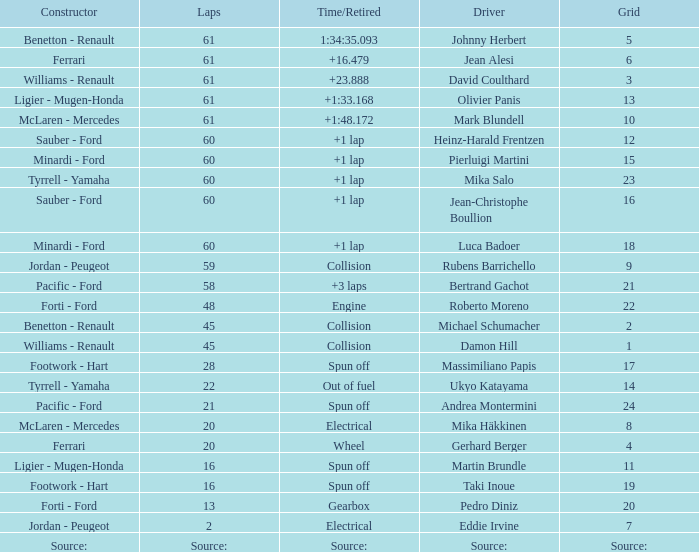Could you help me parse every detail presented in this table? {'header': ['Constructor', 'Laps', 'Time/Retired', 'Driver', 'Grid'], 'rows': [['Benetton - Renault', '61', '1:34:35.093', 'Johnny Herbert', '5'], ['Ferrari', '61', '+16.479', 'Jean Alesi', '6'], ['Williams - Renault', '61', '+23.888', 'David Coulthard', '3'], ['Ligier - Mugen-Honda', '61', '+1:33.168', 'Olivier Panis', '13'], ['McLaren - Mercedes', '61', '+1:48.172', 'Mark Blundell', '10'], ['Sauber - Ford', '60', '+1 lap', 'Heinz-Harald Frentzen', '12'], ['Minardi - Ford', '60', '+1 lap', 'Pierluigi Martini', '15'], ['Tyrrell - Yamaha', '60', '+1 lap', 'Mika Salo', '23'], ['Sauber - Ford', '60', '+1 lap', 'Jean-Christophe Boullion', '16'], ['Minardi - Ford', '60', '+1 lap', 'Luca Badoer', '18'], ['Jordan - Peugeot', '59', 'Collision', 'Rubens Barrichello', '9'], ['Pacific - Ford', '58', '+3 laps', 'Bertrand Gachot', '21'], ['Forti - Ford', '48', 'Engine', 'Roberto Moreno', '22'], ['Benetton - Renault', '45', 'Collision', 'Michael Schumacher', '2'], ['Williams - Renault', '45', 'Collision', 'Damon Hill', '1'], ['Footwork - Hart', '28', 'Spun off', 'Massimiliano Papis', '17'], ['Tyrrell - Yamaha', '22', 'Out of fuel', 'Ukyo Katayama', '14'], ['Pacific - Ford', '21', 'Spun off', 'Andrea Montermini', '24'], ['McLaren - Mercedes', '20', 'Electrical', 'Mika Häkkinen', '8'], ['Ferrari', '20', 'Wheel', 'Gerhard Berger', '4'], ['Ligier - Mugen-Honda', '16', 'Spun off', 'Martin Brundle', '11'], ['Footwork - Hart', '16', 'Spun off', 'Taki Inoue', '19'], ['Forti - Ford', '13', 'Gearbox', 'Pedro Diniz', '20'], ['Jordan - Peugeot', '2', 'Electrical', 'Eddie Irvine', '7'], ['Source:', 'Source:', 'Source:', 'Source:', 'Source:']]} How many laps does luca badoer have? 60.0. 